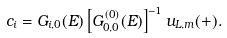<formula> <loc_0><loc_0><loc_500><loc_500>c _ { i } = G _ { i , 0 } ( E ) \left [ G _ { 0 , 0 } ^ { ( 0 ) } ( E ) \right ] ^ { - 1 } u _ { L , m } ( + ) .</formula> 